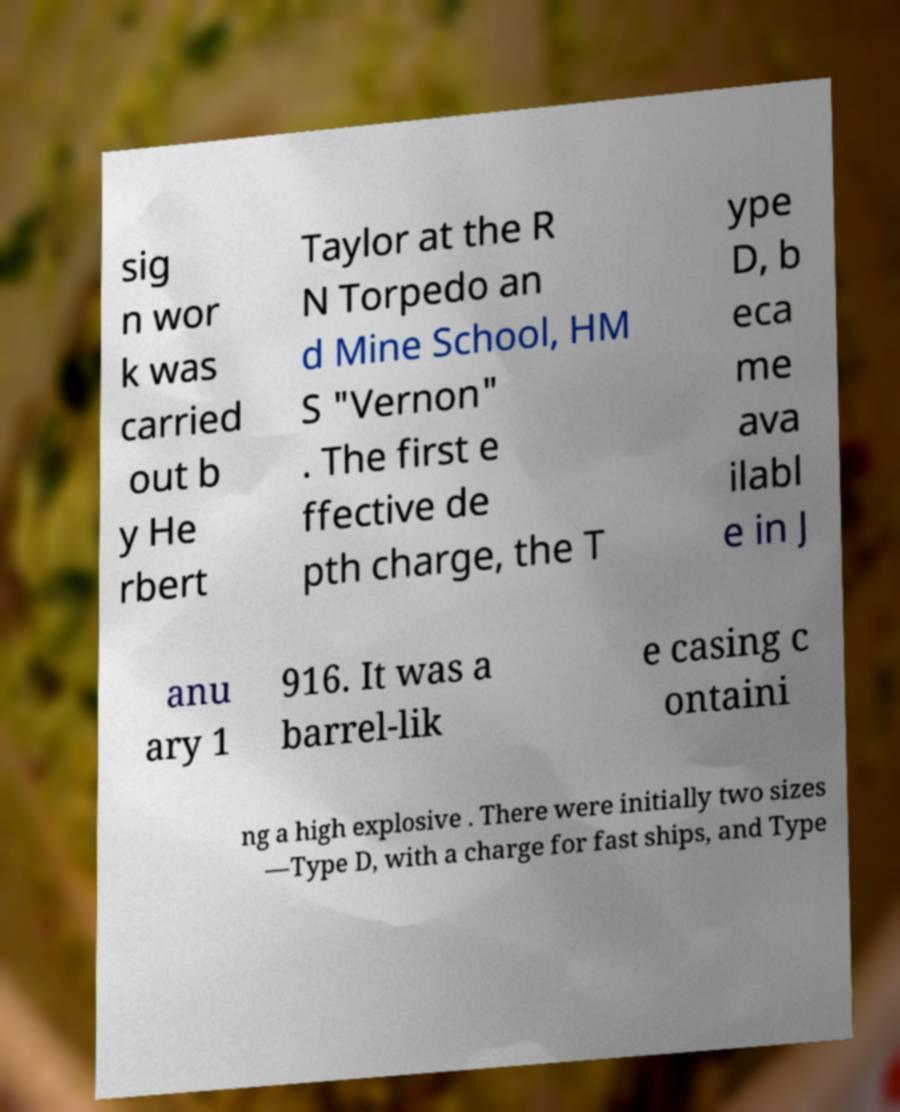Please read and relay the text visible in this image. What does it say? sig n wor k was carried out b y He rbert Taylor at the R N Torpedo an d Mine School, HM S "Vernon" . The first e ffective de pth charge, the T ype D, b eca me ava ilabl e in J anu ary 1 916. It was a barrel-lik e casing c ontaini ng a high explosive . There were initially two sizes —Type D, with a charge for fast ships, and Type 